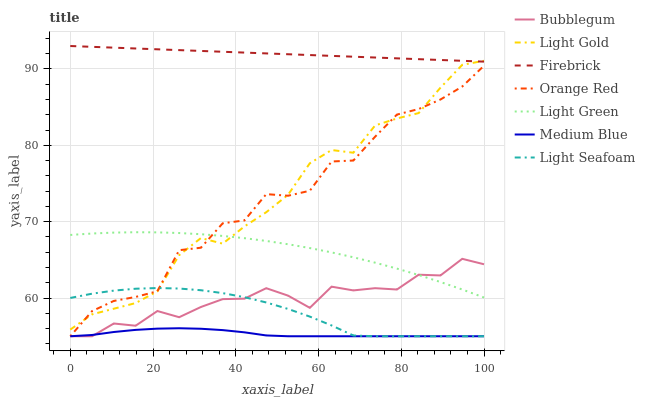Does Bubblegum have the minimum area under the curve?
Answer yes or no. No. Does Bubblegum have the maximum area under the curve?
Answer yes or no. No. Is Medium Blue the smoothest?
Answer yes or no. No. Is Medium Blue the roughest?
Answer yes or no. No. Does Light Green have the lowest value?
Answer yes or no. No. Does Bubblegum have the highest value?
Answer yes or no. No. Is Light Seafoam less than Firebrick?
Answer yes or no. Yes. Is Firebrick greater than Bubblegum?
Answer yes or no. Yes. Does Light Seafoam intersect Firebrick?
Answer yes or no. No. 